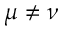<formula> <loc_0><loc_0><loc_500><loc_500>\mu \neq \nu</formula> 